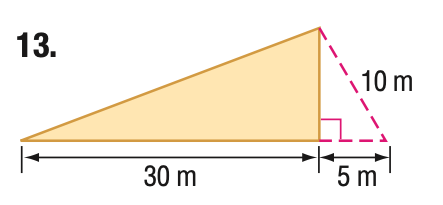Answer the mathemtical geometry problem and directly provide the correct option letter.
Question: Find the area of the triangle. Round to the nearest tenth if necessary.
Choices: A: 75 B: 106.1 C: 129.9 D: 150 C 